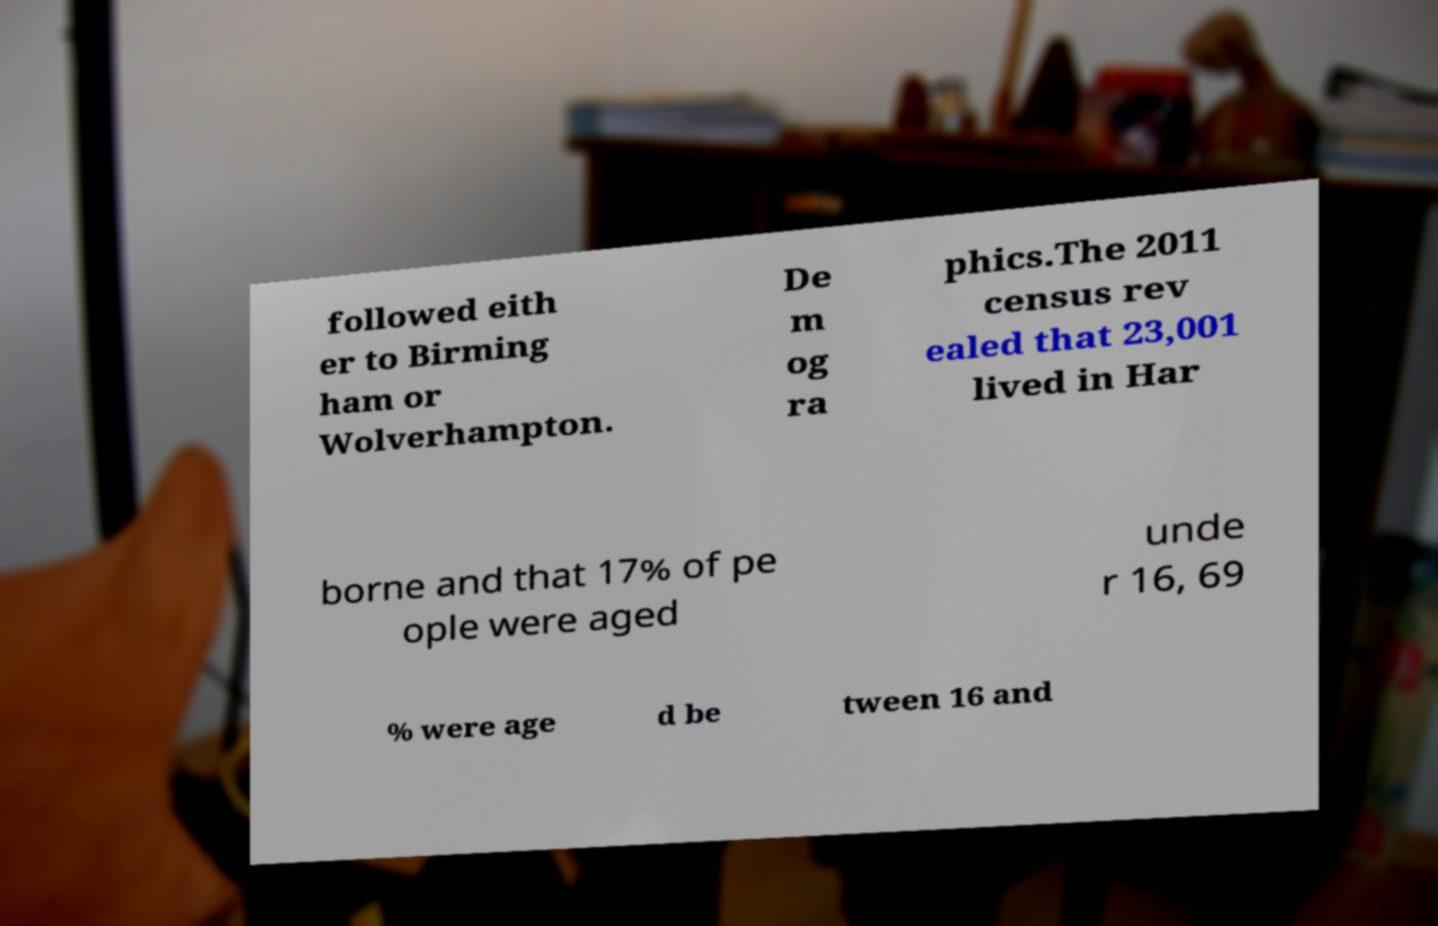Can you read and provide the text displayed in the image?This photo seems to have some interesting text. Can you extract and type it out for me? followed eith er to Birming ham or Wolverhampton. De m og ra phics.The 2011 census rev ealed that 23,001 lived in Har borne and that 17% of pe ople were aged unde r 16, 69 % were age d be tween 16 and 